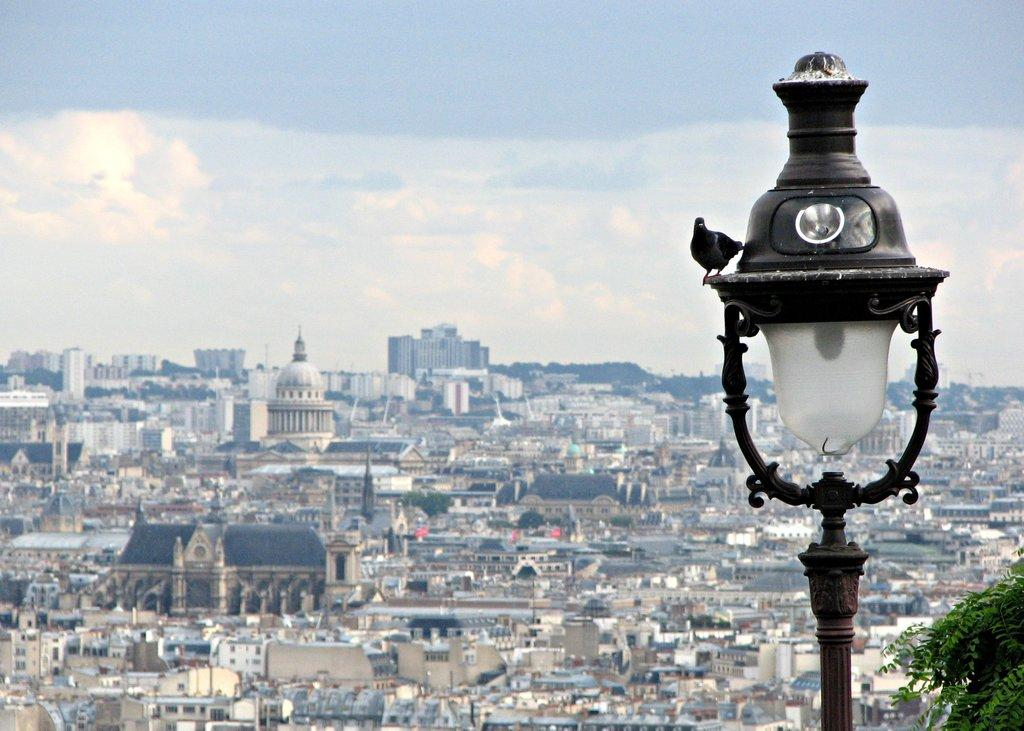What is the perspective of the image? The image shows a top view of city buildings. How would you describe the appearance of the buildings in the image? There is a beautiful view of the buildings in the image. Can you identify any specific objects in the image? Yes, there is a black and white color lamp post in the image. What type of silk is draped over the army vehicles in the image? There are no army vehicles or silk present in the image; it shows a top view of city buildings with a black and white color lamp post. 